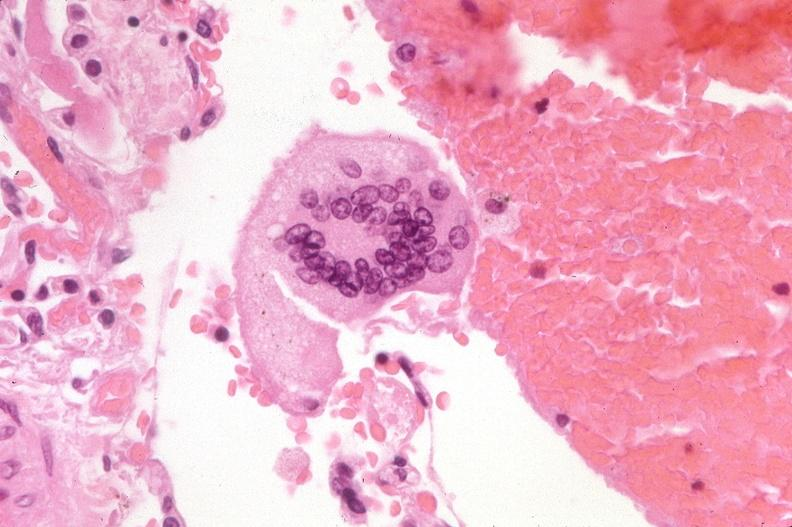what does this image show?
Answer the question using a single word or phrase. Lung 